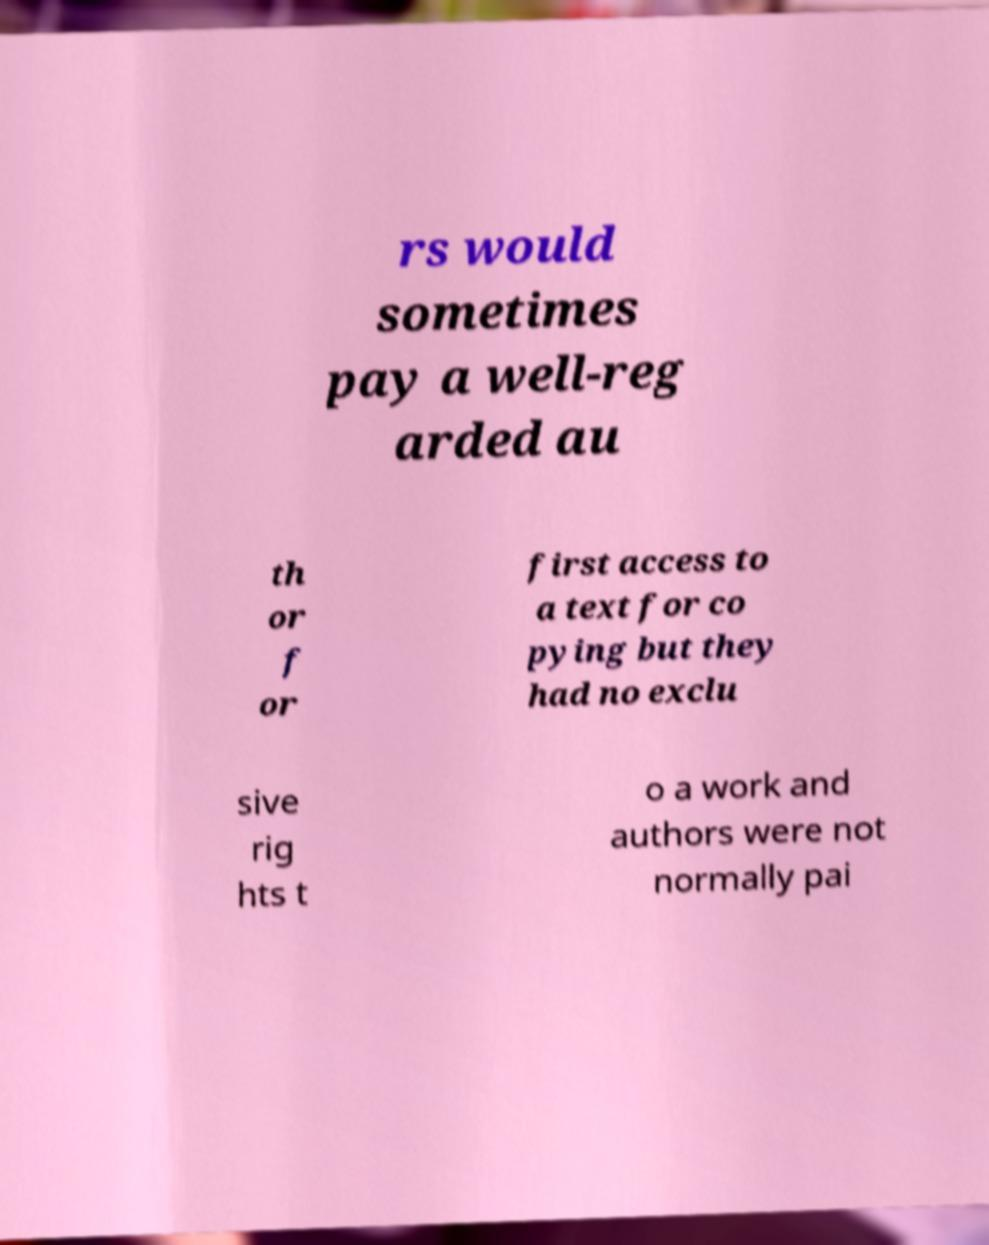Can you read and provide the text displayed in the image?This photo seems to have some interesting text. Can you extract and type it out for me? rs would sometimes pay a well-reg arded au th or f or first access to a text for co pying but they had no exclu sive rig hts t o a work and authors were not normally pai 